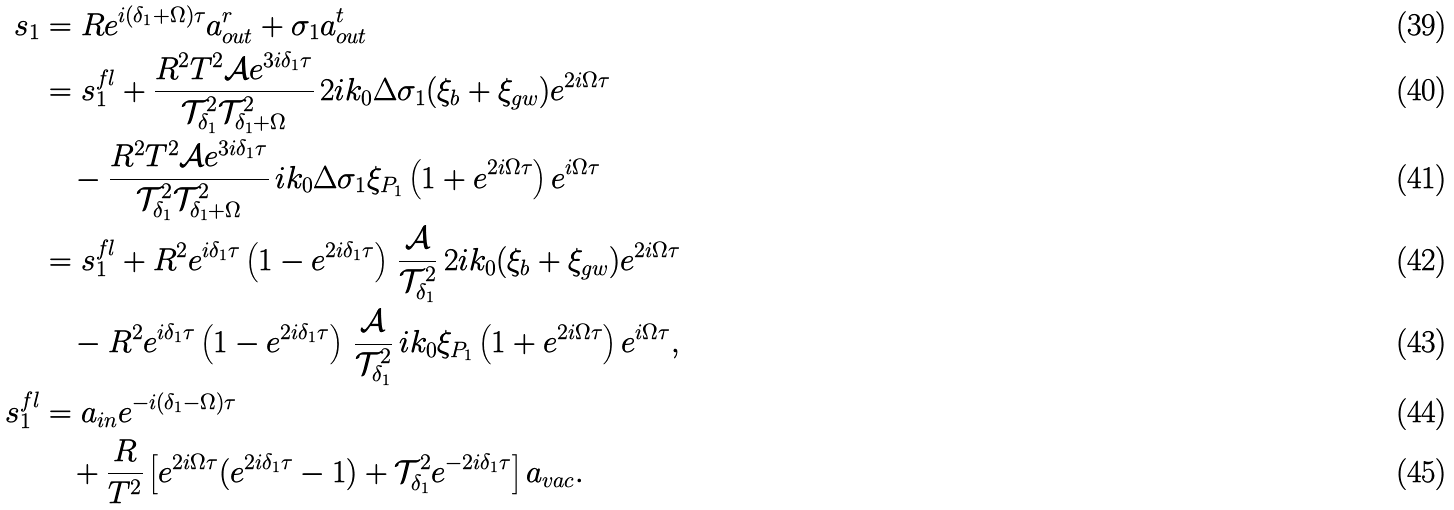Convert formula to latex. <formula><loc_0><loc_0><loc_500><loc_500>s _ { 1 } & = R e ^ { i ( \delta _ { 1 } + \Omega ) \tau } a ^ { r } _ { o u t } + \sigma _ { 1 } a ^ { t } _ { o u t } \\ & = s _ { 1 } ^ { f l } + \frac { R ^ { 2 } T ^ { 2 } \mathcal { A } e ^ { 3 i \delta _ { 1 } \tau } } { \mathcal { T } ^ { 2 } _ { \delta _ { 1 } } \mathcal { T } ^ { 2 } _ { \delta _ { 1 } + \Omega } } \, 2 i k _ { 0 } \Delta \sigma _ { 1 } ( \xi _ { b } + \xi _ { g w } ) e ^ { 2 i \Omega \tau } \\ & \quad - \frac { R ^ { 2 } T ^ { 2 } \mathcal { A } e ^ { 3 i \delta _ { 1 } \tau } } { \mathcal { T } ^ { 2 } _ { \delta _ { 1 } } \mathcal { T } ^ { 2 } _ { \delta _ { 1 } + \Omega } } \, i k _ { 0 } \Delta \sigma _ { 1 } \xi _ { P _ { 1 } } \left ( 1 + e ^ { 2 i \Omega \tau } \right ) e ^ { i \Omega \tau } \\ & = s _ { 1 } ^ { f l } + R ^ { 2 } e ^ { i \delta _ { 1 } \tau } \left ( 1 - e ^ { 2 i \delta _ { 1 } \tau } \right ) \, \frac { \mathcal { A } } { \mathcal { T } ^ { 2 } _ { \delta _ { 1 } } } \, 2 i k _ { 0 } ( \xi _ { b } + \xi _ { g w } ) e ^ { 2 i \Omega \tau } \\ & \quad - R ^ { 2 } e ^ { i \delta _ { 1 } \tau } \left ( 1 - e ^ { 2 i \delta _ { 1 } \tau } \right ) \, \frac { \mathcal { A } } { \mathcal { T } ^ { 2 } _ { \delta _ { 1 } } } \, i k _ { 0 } \xi _ { P _ { 1 } } \left ( 1 + e ^ { 2 i \Omega \tau } \right ) e ^ { i \Omega \tau } , \\ s _ { 1 } ^ { f l } & = a _ { i n } e ^ { - i ( \delta _ { 1 } - \Omega ) \tau } \\ & \quad + \frac { R } { T ^ { 2 } } \left [ e ^ { 2 i \Omega \tau } ( e ^ { 2 i \delta _ { 1 } \tau } - 1 ) + \mathcal { T } ^ { 2 } _ { \delta _ { 1 } } e ^ { - 2 i \delta _ { 1 } \tau } \right ] a _ { v a c } .</formula> 